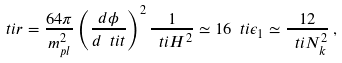Convert formula to latex. <formula><loc_0><loc_0><loc_500><loc_500>\ t i { r } = \frac { 6 4 \pi } { m _ { p l } ^ { 2 } } \left ( \frac { d \phi } { d \ t i { t } } \right ) ^ { 2 } \frac { 1 } { \ t i { H } ^ { 2 } } \simeq 1 6 \ t i { \epsilon } _ { 1 } \simeq \frac { 1 2 } { \ t i { N } _ { k } ^ { 2 } } \, ,</formula> 